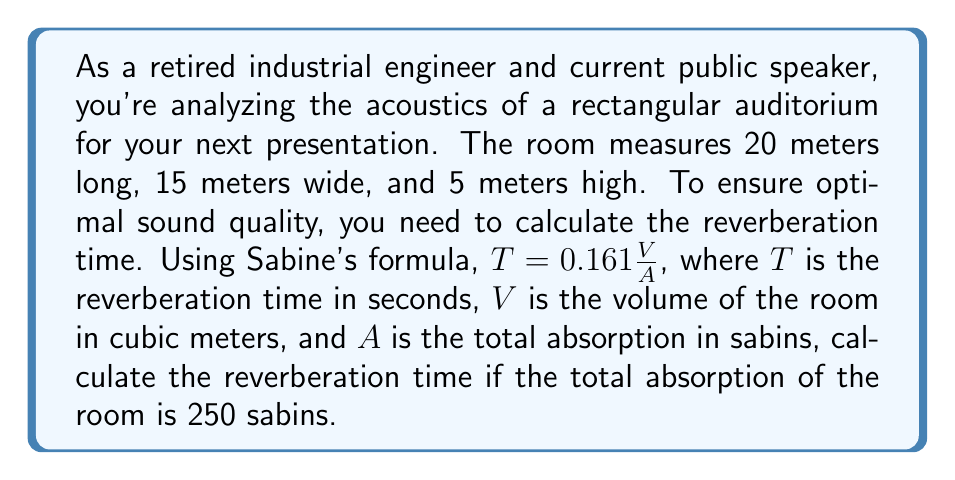Can you answer this question? To solve this problem, we'll follow these steps:

1. Calculate the volume of the auditorium:
   $$V = \text{length} \times \text{width} \times \text{height}$$
   $$V = 20 \text{ m} \times 15 \text{ m} \times 5 \text{ m} = 1500 \text{ m}^3$$

2. Use Sabine's formula to calculate the reverberation time:
   $$T = 0.161 \frac{V}{A}$$
   
   Where:
   $T$ = reverberation time in seconds
   $V$ = volume of the room in cubic meters (1500 m³)
   $A$ = total absorption in sabins (given as 250 sabins)

3. Substitute the values into the formula:
   $$T = 0.161 \frac{1500}{250}$$

4. Calculate the result:
   $$T = 0.161 \times 6 = 0.966 \text{ seconds}$$

The reverberation time is approximately 0.97 seconds.

[asy]
import geometry;

// Define the dimensions
real length = 20;
real width = 15;
real height = 5;

// Create the points for the rectangular prism
pair A = (0,0);
pair B = (width,0);
pair C = (width,height);
pair D = (0,height);
pair E = (width-3,3);
pair F = (width-3,height+3);
pair G = (3,height+3);

// Draw the visible faces
draw(A--B--C--D--cycle);
draw(B--E);
draw(C--F);
draw(D--G);
draw(E--F--G);

// Label the dimensions
label("20 m", (width/2,-0.5));
label("15 m", (width+0.5,height/2));
label("5 m", (-0.5,height/2));

// Add a title
label("Rectangular Auditorium", (width/2,height+4));
[/asy]
Answer: The reverberation time of the auditorium is approximately 0.97 seconds. 